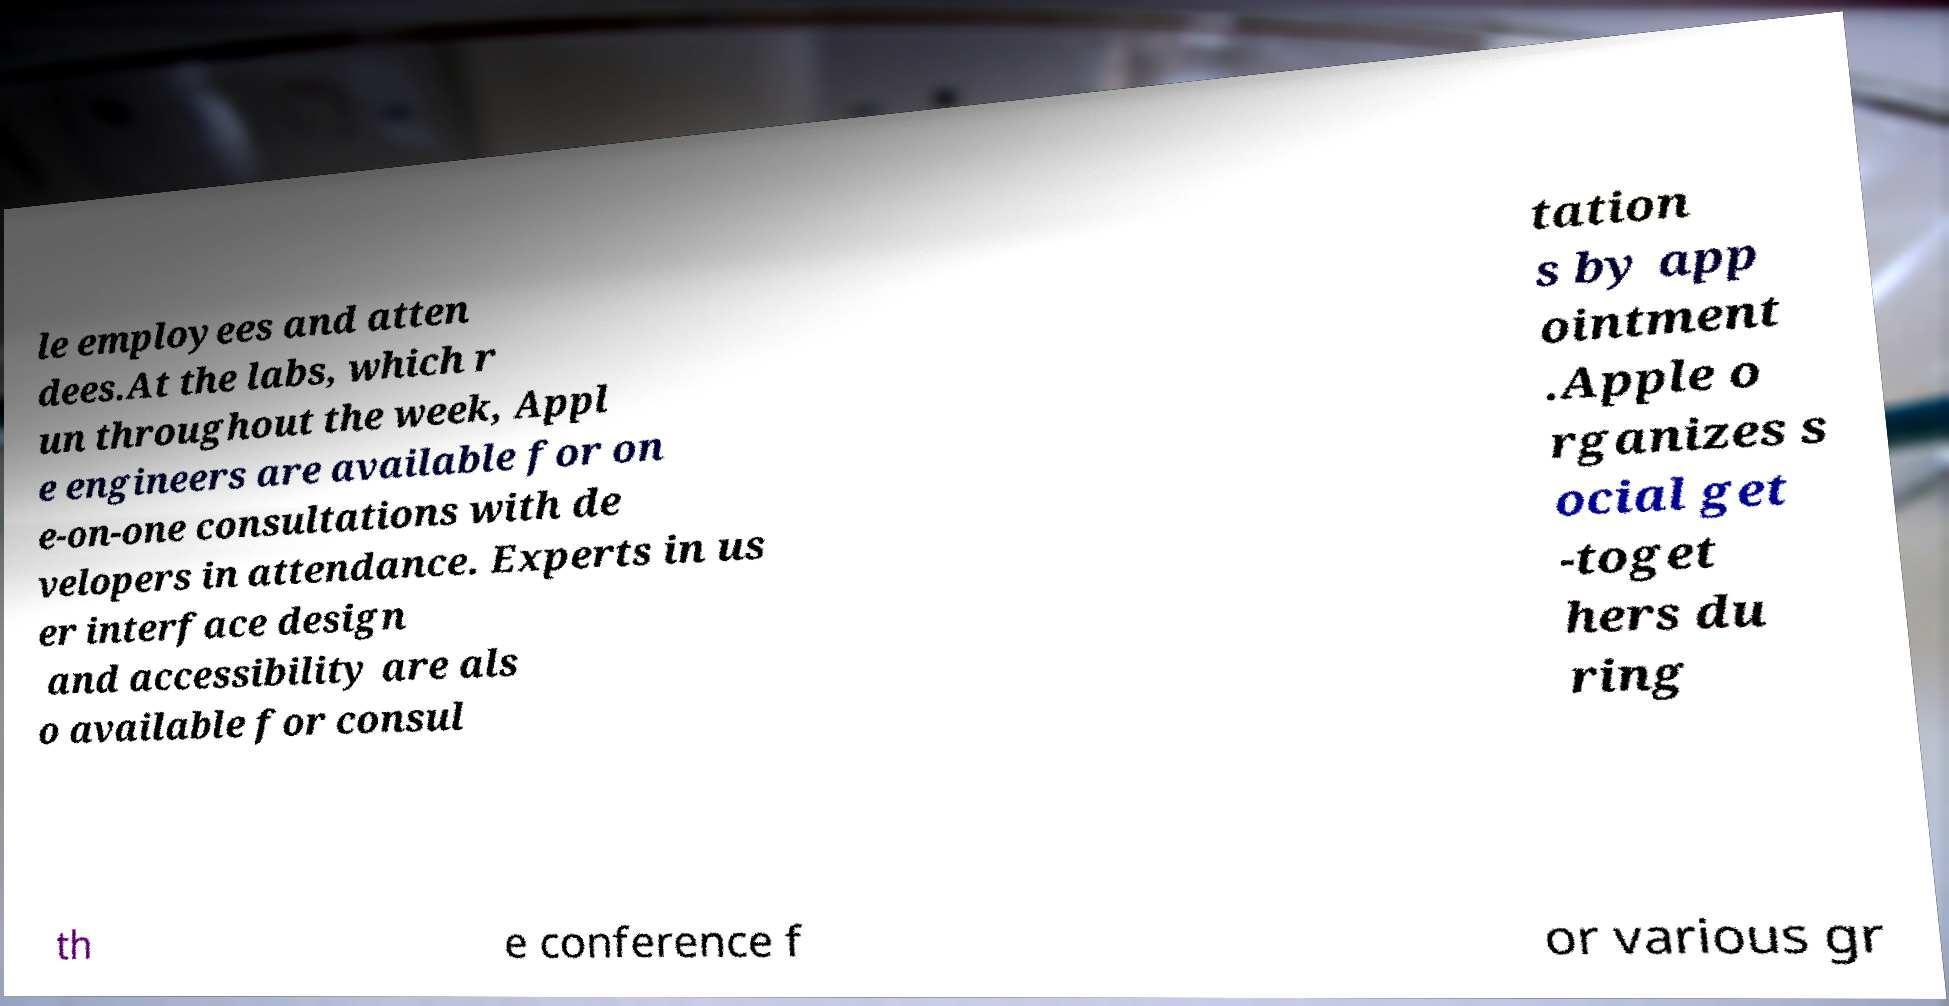What messages or text are displayed in this image? I need them in a readable, typed format. le employees and atten dees.At the labs, which r un throughout the week, Appl e engineers are available for on e-on-one consultations with de velopers in attendance. Experts in us er interface design and accessibility are als o available for consul tation s by app ointment .Apple o rganizes s ocial get -toget hers du ring th e conference f or various gr 